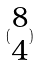Convert formula to latex. <formula><loc_0><loc_0><loc_500><loc_500>( \begin{matrix} 8 \\ 4 \end{matrix} )</formula> 